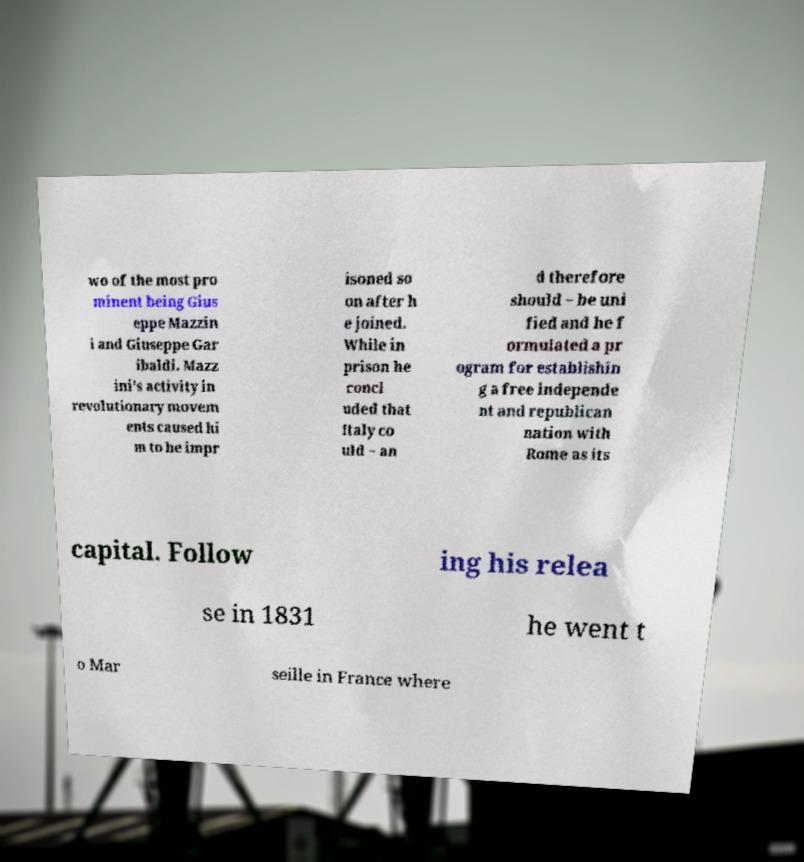Could you extract and type out the text from this image? wo of the most pro minent being Gius eppe Mazzin i and Giuseppe Gar ibaldi. Mazz ini's activity in revolutionary movem ents caused hi m to be impr isoned so on after h e joined. While in prison he concl uded that Italy co uld − an d therefore should − be uni fied and he f ormulated a pr ogram for establishin g a free independe nt and republican nation with Rome as its capital. Follow ing his relea se in 1831 he went t o Mar seille in France where 